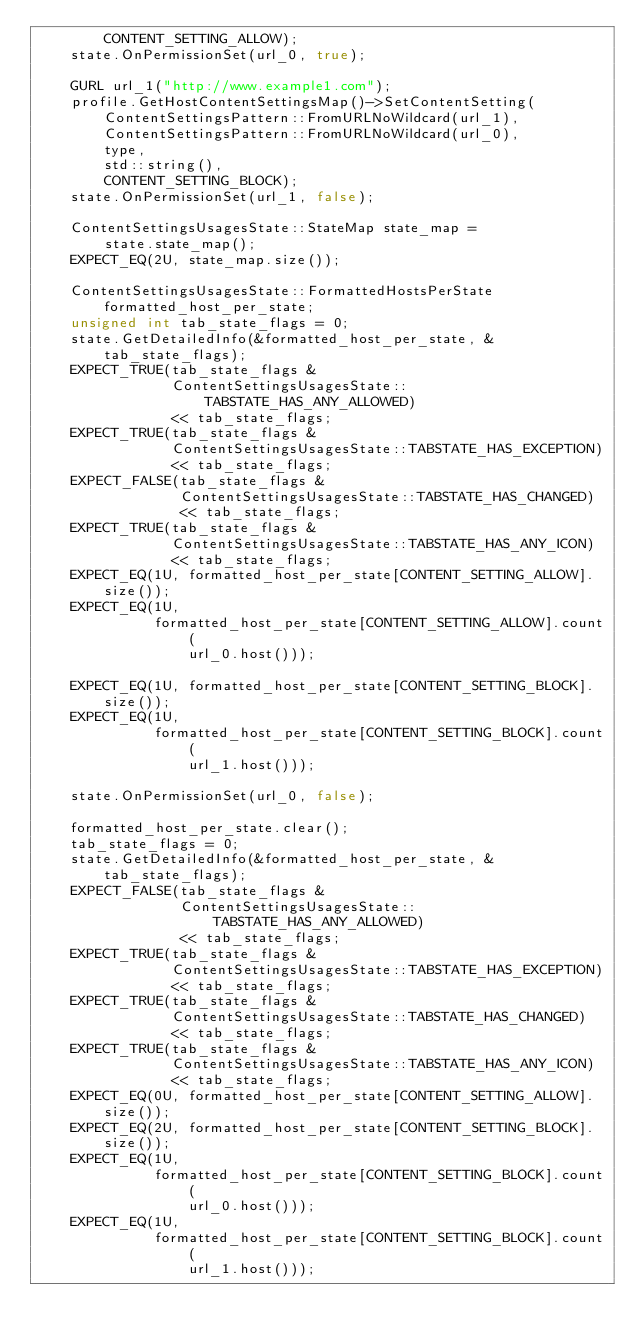Convert code to text. <code><loc_0><loc_0><loc_500><loc_500><_C++_>        CONTENT_SETTING_ALLOW);
    state.OnPermissionSet(url_0, true);

    GURL url_1("http://www.example1.com");
    profile.GetHostContentSettingsMap()->SetContentSetting(
        ContentSettingsPattern::FromURLNoWildcard(url_1),
        ContentSettingsPattern::FromURLNoWildcard(url_0),
        type,
        std::string(),
        CONTENT_SETTING_BLOCK);
    state.OnPermissionSet(url_1, false);

    ContentSettingsUsagesState::StateMap state_map =
        state.state_map();
    EXPECT_EQ(2U, state_map.size());

    ContentSettingsUsagesState::FormattedHostsPerState formatted_host_per_state;
    unsigned int tab_state_flags = 0;
    state.GetDetailedInfo(&formatted_host_per_state, &tab_state_flags);
    EXPECT_TRUE(tab_state_flags &
                ContentSettingsUsagesState::TABSTATE_HAS_ANY_ALLOWED)
                << tab_state_flags;
    EXPECT_TRUE(tab_state_flags &
                ContentSettingsUsagesState::TABSTATE_HAS_EXCEPTION)
                << tab_state_flags;
    EXPECT_FALSE(tab_state_flags &
                 ContentSettingsUsagesState::TABSTATE_HAS_CHANGED)
                 << tab_state_flags;
    EXPECT_TRUE(tab_state_flags &
                ContentSettingsUsagesState::TABSTATE_HAS_ANY_ICON)
                << tab_state_flags;
    EXPECT_EQ(1U, formatted_host_per_state[CONTENT_SETTING_ALLOW].size());
    EXPECT_EQ(1U,
              formatted_host_per_state[CONTENT_SETTING_ALLOW].count(
                  url_0.host()));

    EXPECT_EQ(1U, formatted_host_per_state[CONTENT_SETTING_BLOCK].size());
    EXPECT_EQ(1U,
              formatted_host_per_state[CONTENT_SETTING_BLOCK].count(
                  url_1.host()));

    state.OnPermissionSet(url_0, false);

    formatted_host_per_state.clear();
    tab_state_flags = 0;
    state.GetDetailedInfo(&formatted_host_per_state, &tab_state_flags);
    EXPECT_FALSE(tab_state_flags &
                 ContentSettingsUsagesState::TABSTATE_HAS_ANY_ALLOWED)
                 << tab_state_flags;
    EXPECT_TRUE(tab_state_flags &
                ContentSettingsUsagesState::TABSTATE_HAS_EXCEPTION)
                << tab_state_flags;
    EXPECT_TRUE(tab_state_flags &
                ContentSettingsUsagesState::TABSTATE_HAS_CHANGED)
                << tab_state_flags;
    EXPECT_TRUE(tab_state_flags &
                ContentSettingsUsagesState::TABSTATE_HAS_ANY_ICON)
                << tab_state_flags;
    EXPECT_EQ(0U, formatted_host_per_state[CONTENT_SETTING_ALLOW].size());
    EXPECT_EQ(2U, formatted_host_per_state[CONTENT_SETTING_BLOCK].size());
    EXPECT_EQ(1U,
              formatted_host_per_state[CONTENT_SETTING_BLOCK].count(
                  url_0.host()));
    EXPECT_EQ(1U,
              formatted_host_per_state[CONTENT_SETTING_BLOCK].count(
                  url_1.host()));
</code> 